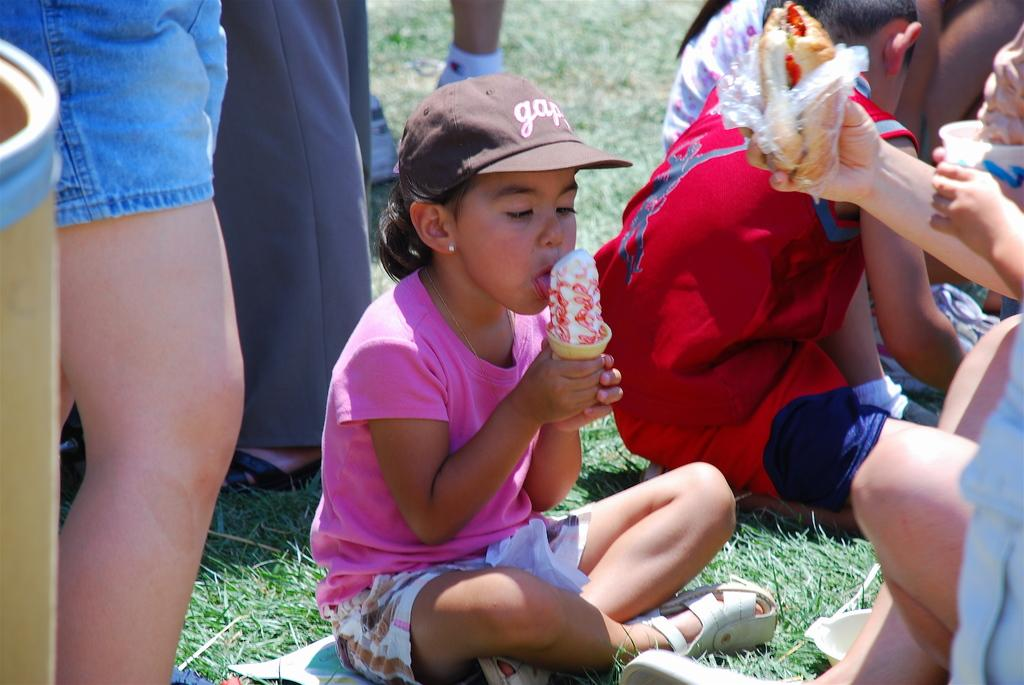Provide a one-sentence caption for the provided image. a girl eating icecream wearing a Gap hat. 